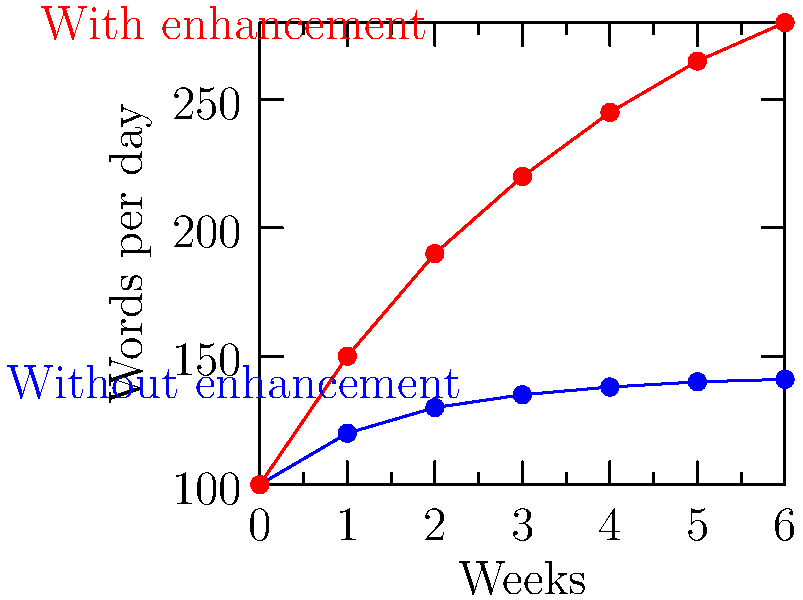The graph shows the daily word output of a writer over six weeks, both with and without creativity-boosting methods. After six weeks, approximately how many more words per day does the writer produce using enhancement techniques compared to their baseline output? To solve this problem, we need to follow these steps:

1. Identify the final word counts for both scenarios at week 6:
   - Without enhancement (blue line): approximately 141 words per day
   - With enhancement (red line): approximately 280 words per day

2. Calculate the difference between these two values:
   $280 - 141 = 139$ words per day

3. Round the result to the nearest 10 for a more general estimate:
   139 rounds to 140 words per day

This calculation shows that after six weeks, the writer produces about 140 more words per day when using creativity-boosting methods compared to their output without enhancement.
Answer: 140 words 